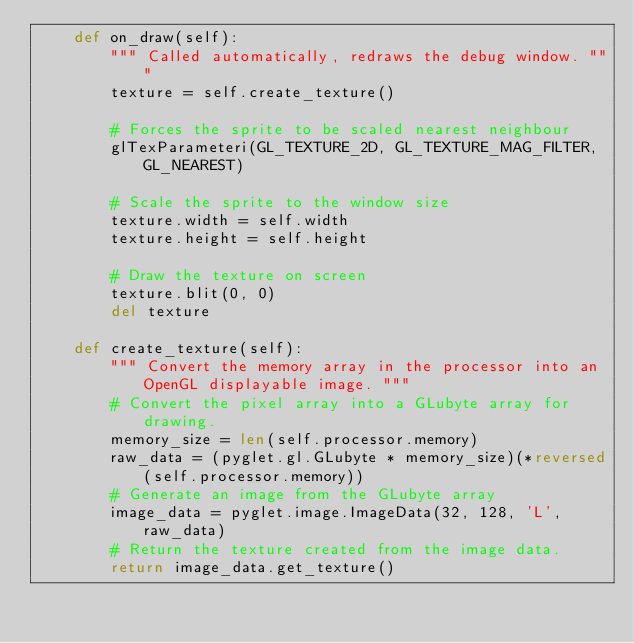Convert code to text. <code><loc_0><loc_0><loc_500><loc_500><_Python_>    def on_draw(self):
        """ Called automatically, redraws the debug window. """
        texture = self.create_texture()

        # Forces the sprite to be scaled nearest neighbour
        glTexParameteri(GL_TEXTURE_2D, GL_TEXTURE_MAG_FILTER, GL_NEAREST)

        # Scale the sprite to the window size
        texture.width = self.width
        texture.height = self.height

        # Draw the texture on screen
        texture.blit(0, 0)
        del texture

    def create_texture(self):
        """ Convert the memory array in the processor into an OpenGL displayable image. """
        # Convert the pixel array into a GLubyte array for drawing.
        memory_size = len(self.processor.memory)
        raw_data = (pyglet.gl.GLubyte * memory_size)(*reversed(self.processor.memory))
        # Generate an image from the GLubyte array
        image_data = pyglet.image.ImageData(32, 128, 'L', raw_data)
        # Return the texture created from the image data.
        return image_data.get_texture()
</code> 